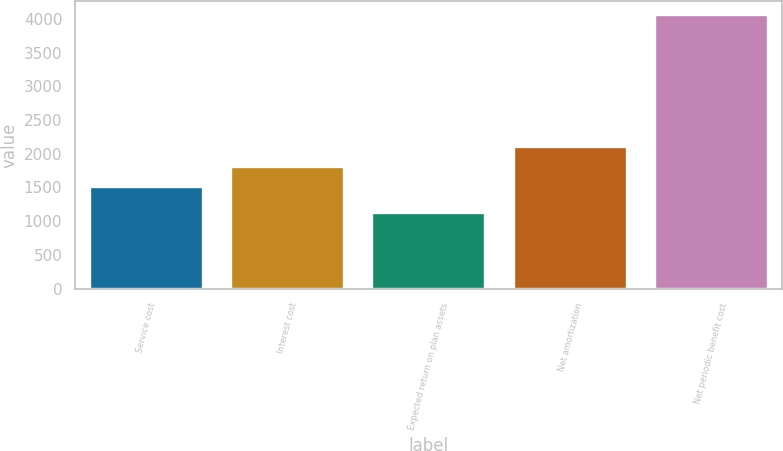Convert chart to OTSL. <chart><loc_0><loc_0><loc_500><loc_500><bar_chart><fcel>Service cost<fcel>Interest cost<fcel>Expected return on plan assets<fcel>Net amortization<fcel>Net periodic benefit cost<nl><fcel>1506<fcel>1800.3<fcel>1114<fcel>2094.6<fcel>4057<nl></chart> 